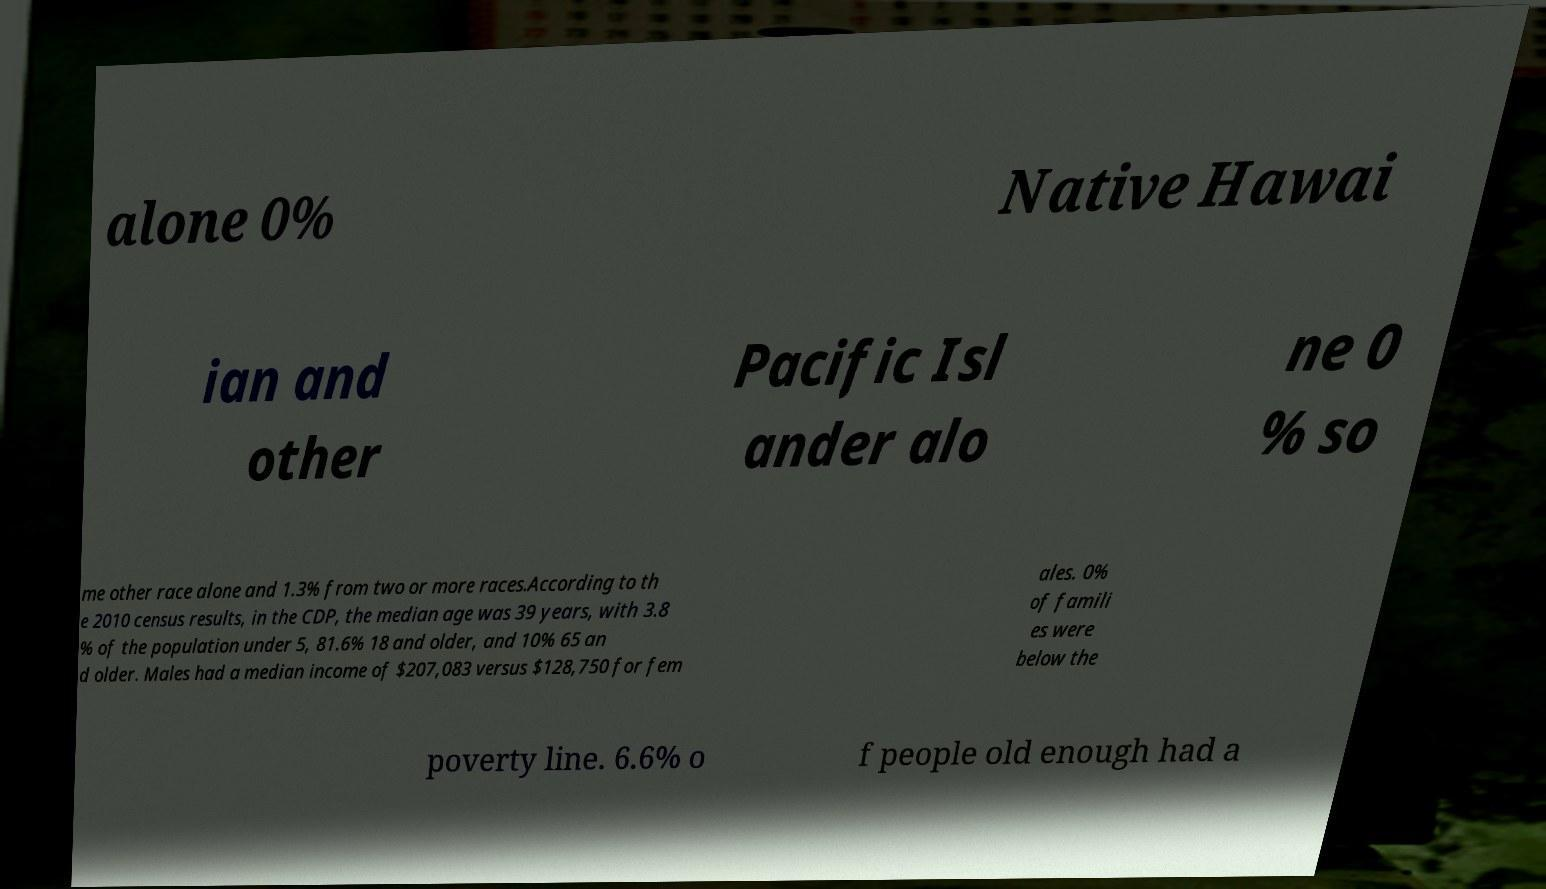For documentation purposes, I need the text within this image transcribed. Could you provide that? alone 0% Native Hawai ian and other Pacific Isl ander alo ne 0 % so me other race alone and 1.3% from two or more races.According to th e 2010 census results, in the CDP, the median age was 39 years, with 3.8 % of the population under 5, 81.6% 18 and older, and 10% 65 an d older. Males had a median income of $207,083 versus $128,750 for fem ales. 0% of famili es were below the poverty line. 6.6% o f people old enough had a 